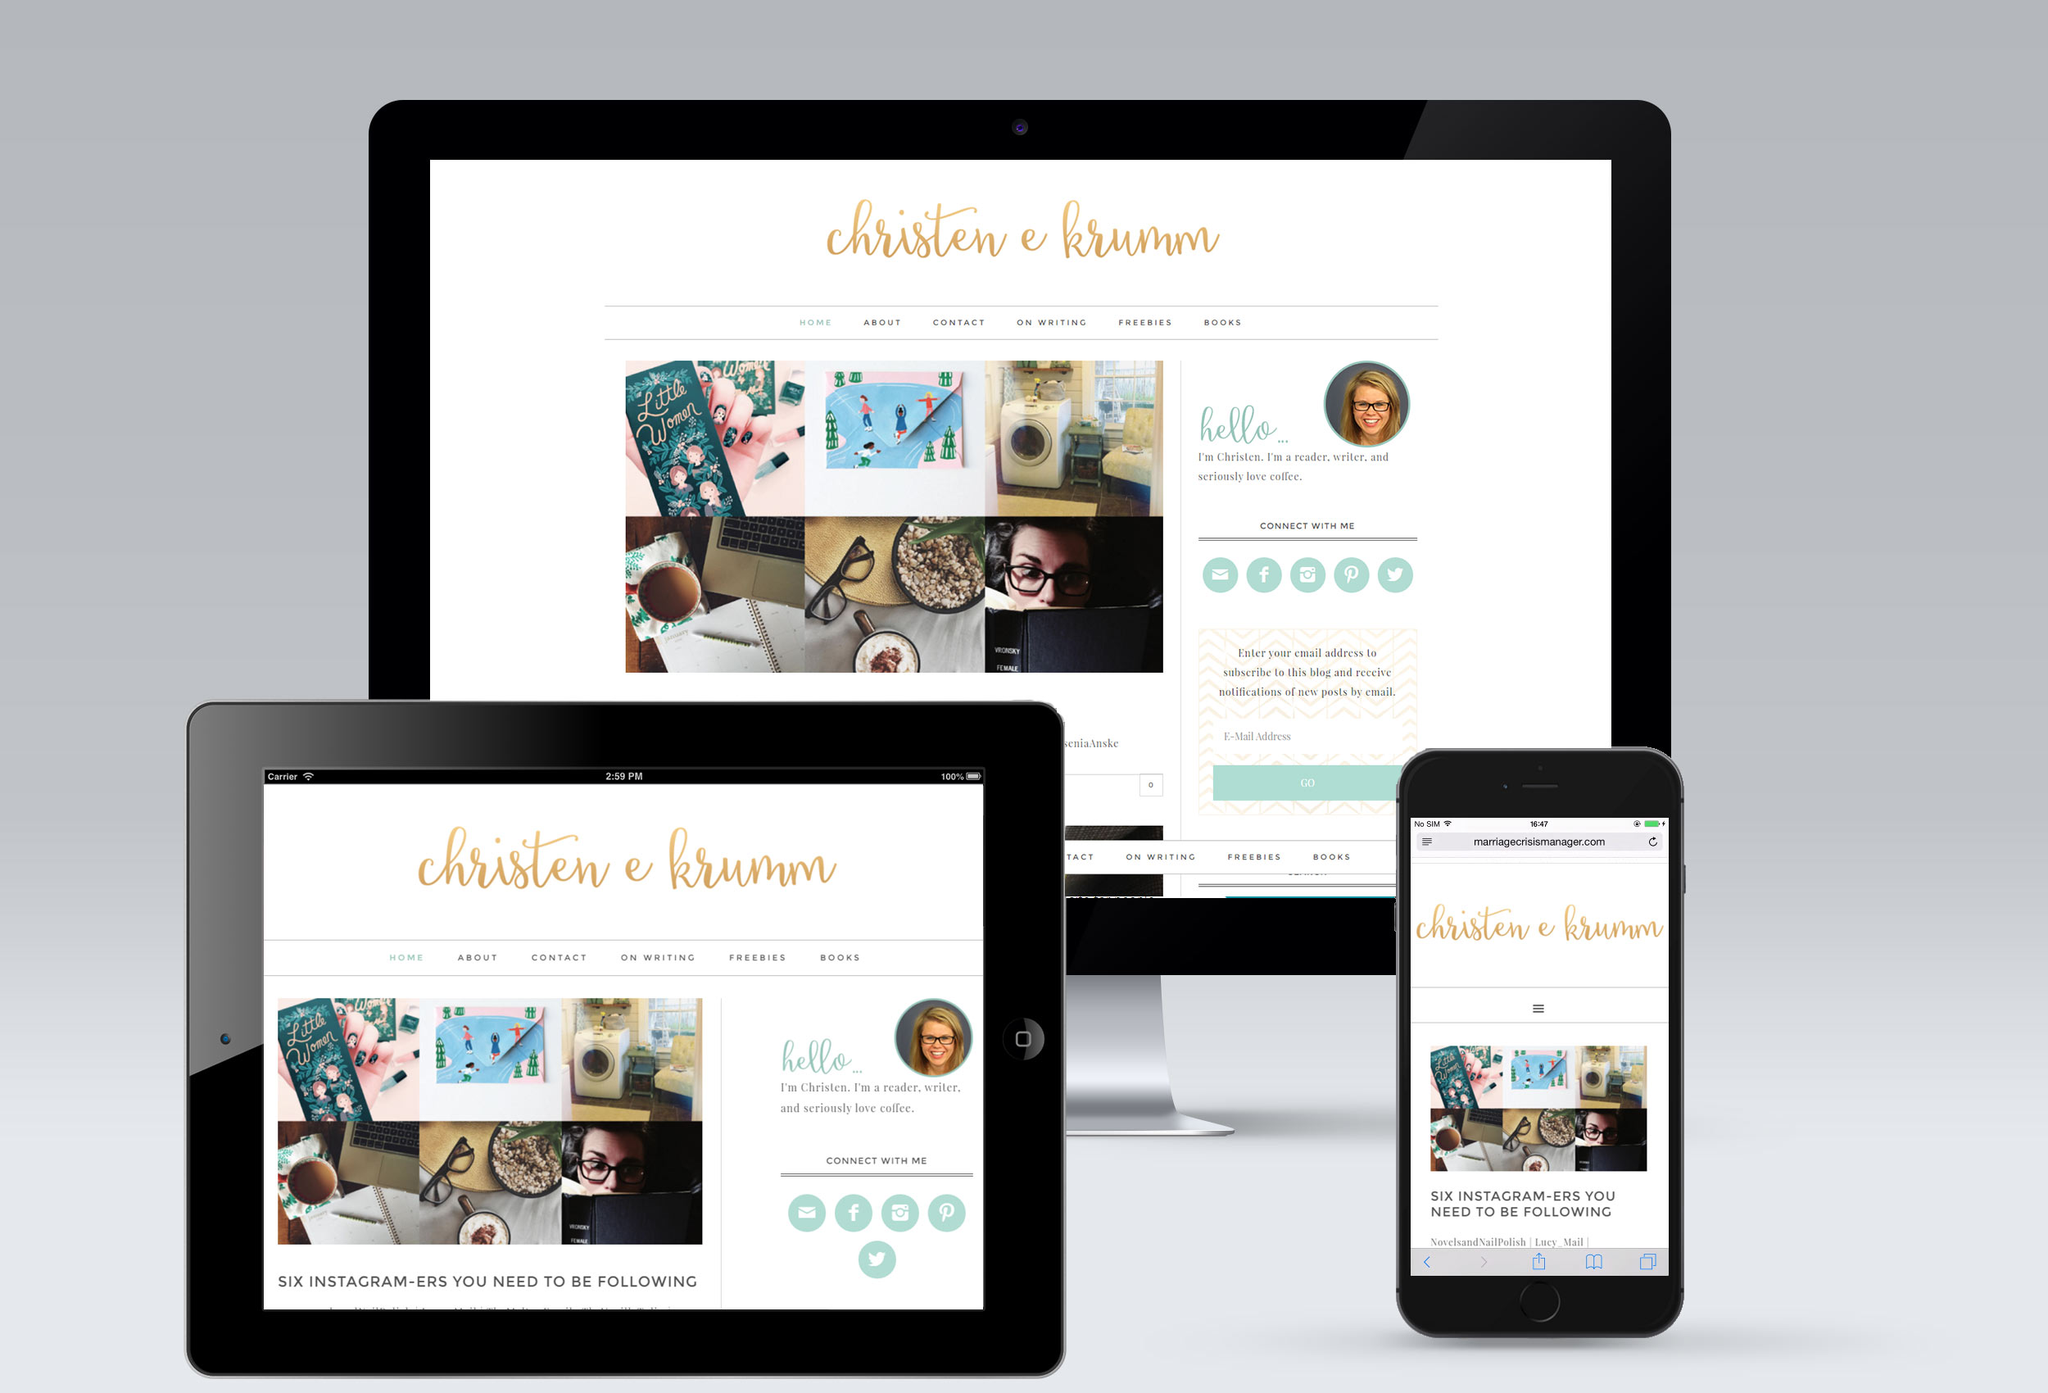What design elements are used in the website's layout that might help in attracting its target audience? The website utilizes a clean, minimalist design with a clear and easy-to-navigate layout. Pastel colors and soft, natural lighting are used, which can be pleasing and engaging to the eye, enhancing the reader's experience and comfort. The use of personal photos and friendly, conversational text invites visitors to feel connected and welcomed, aligning perfectly with the website’s aim to appeal to those interested in personal stories and lifestyle improvements. 